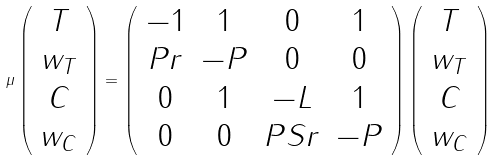<formula> <loc_0><loc_0><loc_500><loc_500>\mu \left ( \begin{array} { c } T \\ w _ { T } \\ C \\ w _ { C } \end{array} \right ) = \left ( \begin{array} { c c c c } - 1 & 1 & 0 & 1 \\ P r & - P & 0 & 0 \\ 0 & 1 & - L & 1 \\ 0 & 0 & P S r & - P \end{array} \right ) \left ( \begin{array} { c } T \\ w _ { T } \\ C \\ w _ { C } \end{array} \right )</formula> 